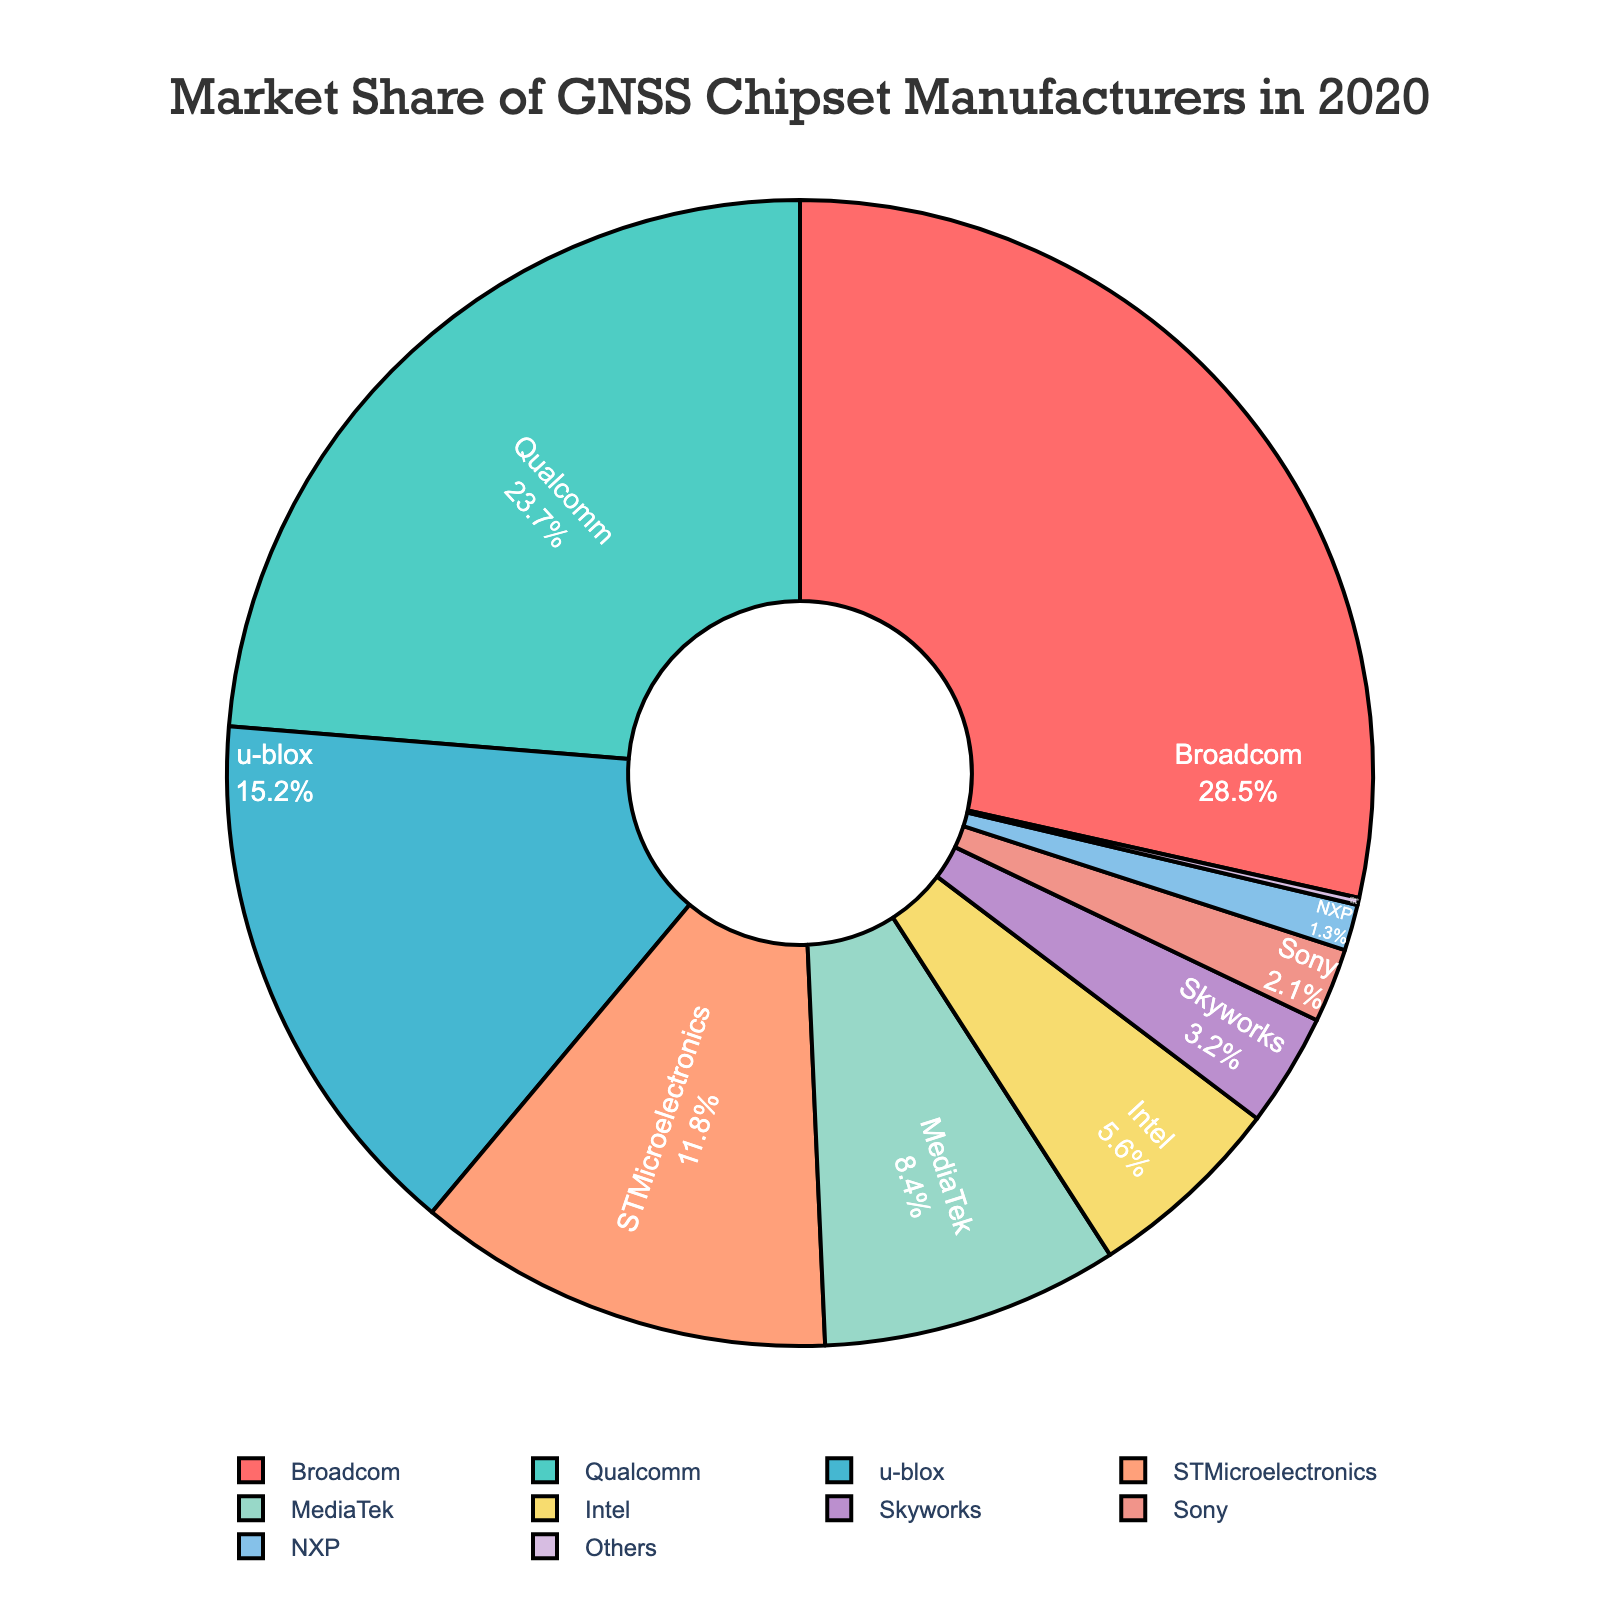What is the market share of Broadcom? Look at the pie chart slice labeled "Broadcom" and note down its percentage value
Answer: 28.5% Which two companies have the closest market shares, and what are those values? Compare the market share percentages and identify the two closest values
Answer: MediaTek (8.4%) and Intel (5.6%) What is the combined market share of Broadcom and Qualcomm? Add the market share percentages of Broadcom and Qualcomm
Answer: 28.5% + 23.7% = 52.2% Which company holds a smaller market share: Skyworks or Sony? Compare the market share percentages of Skyworks and Sony
Answer: Sony What is the difference in market share between u-blox and STMicroelectronics? Subtract STMicroelectronics' market share from u-blox's market share
Answer: 15.2% - 11.8% = 3.4% What percentage of the market is held by the bottom three companies (Skyworks, Sony, and NXP)? Add the market share percentages of Skyworks, Sony, and NXP
Answer: 3.2% + 2.1% + 1.3% = 6.6% Which company has a market share represented by the darkest slice in the color scheme? Find the company associated with the visually darkest-colored slice in the chart
Answer: Broadcom (dark red) How does the market share of u-blox compare to that of Intel and MediaTek combined? Compare the market share of u-blox with the sum of market shares of Intel and MediaTek
Answer: u-blox (15.2%) is greater than Intel + MediaTek (14%) Which company holds the largest market share, and how does it compare to the sum of all "Others"? Identify the company with the largest market share and compare it to the sum of the market share of "Others"
Answer: Broadcom with 28.5% compared to Others with 0.2% 